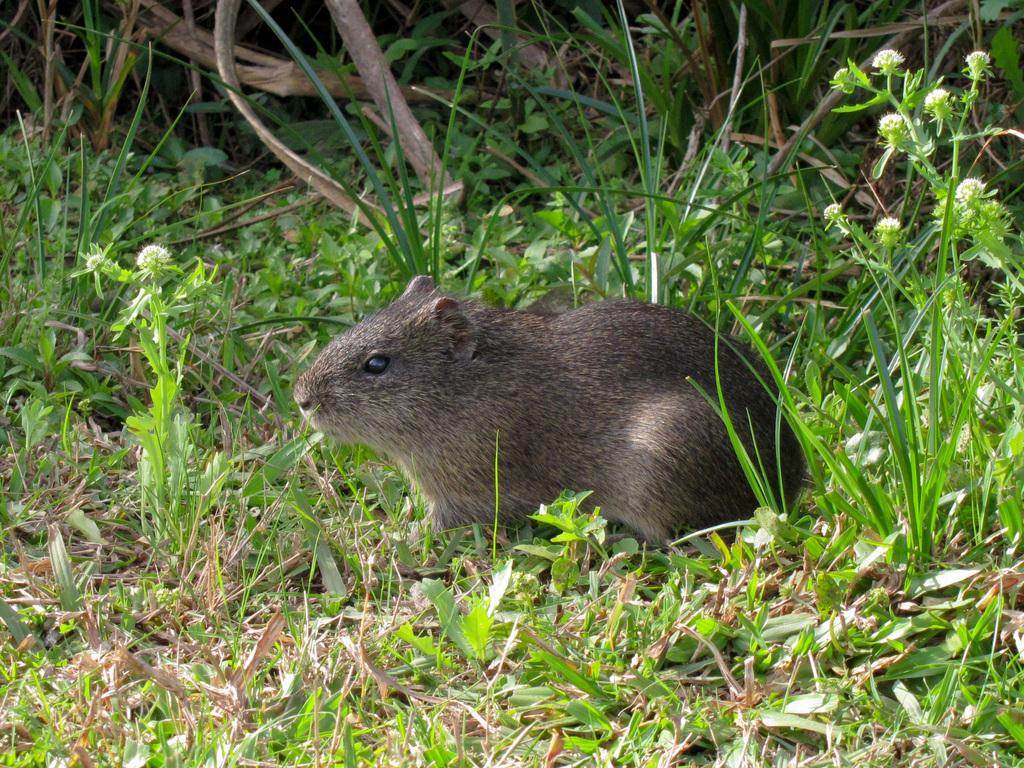What type of animal is in the image? There is a mammal in the image. What else can be seen in the image besides the mammal? There are plants and grass on the ground in the image. How many trucks are parked on the grass in the image? There are no trucks present in the image; it features a mammal and plants on grass. What type of sofa can be seen in the background of the image? There is no sofa present in the image. 